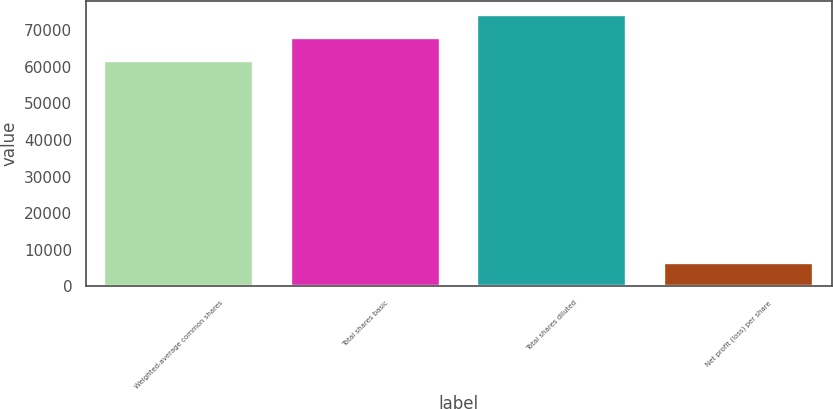Convert chart. <chart><loc_0><loc_0><loc_500><loc_500><bar_chart><fcel>Weighted-average common shares<fcel>Total shares basic<fcel>Total shares diluted<fcel>Net profit (loss) per share<nl><fcel>61644<fcel>67959.2<fcel>74274.4<fcel>6315.22<nl></chart> 